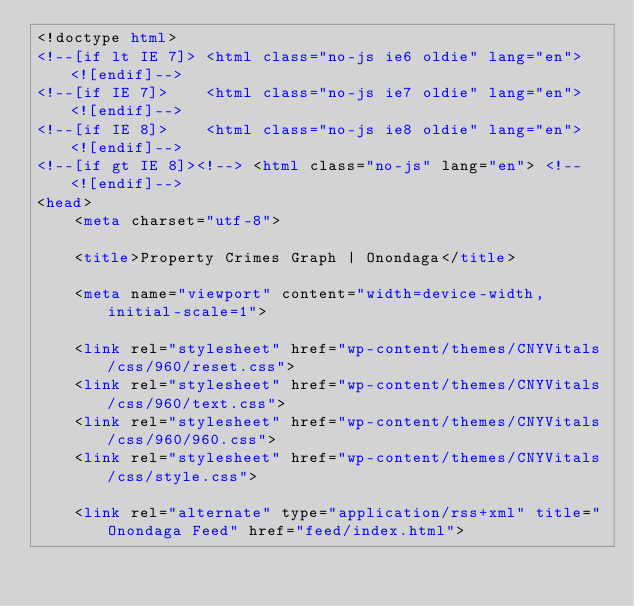Convert code to text. <code><loc_0><loc_0><loc_500><loc_500><_HTML_><!doctype html>
<!--[if lt IE 7]> <html class="no-js ie6 oldie" lang="en"> <![endif]-->
<!--[if IE 7]>    <html class="no-js ie7 oldie" lang="en"> <![endif]-->
<!--[if IE 8]>    <html class="no-js ie8 oldie" lang="en"> <![endif]-->
<!--[if gt IE 8]><!--> <html class="no-js" lang="en"> <!--<![endif]-->
<head>
	<meta charset="utf-8">

	<title>Property Crimes Graph | Onondaga</title>
	
	<meta name="viewport" content="width=device-width,initial-scale=1">

	<link rel="stylesheet" href="wp-content/themes/CNYVitals/css/960/reset.css">
	<link rel="stylesheet" href="wp-content/themes/CNYVitals/css/960/text.css">
	<link rel="stylesheet" href="wp-content/themes/CNYVitals/css/960/960.css">
	<link rel="stylesheet" href="wp-content/themes/CNYVitals/css/style.css">
	
	<link rel="alternate" type="application/rss+xml" title="Onondaga Feed" href="feed/index.html"></code> 